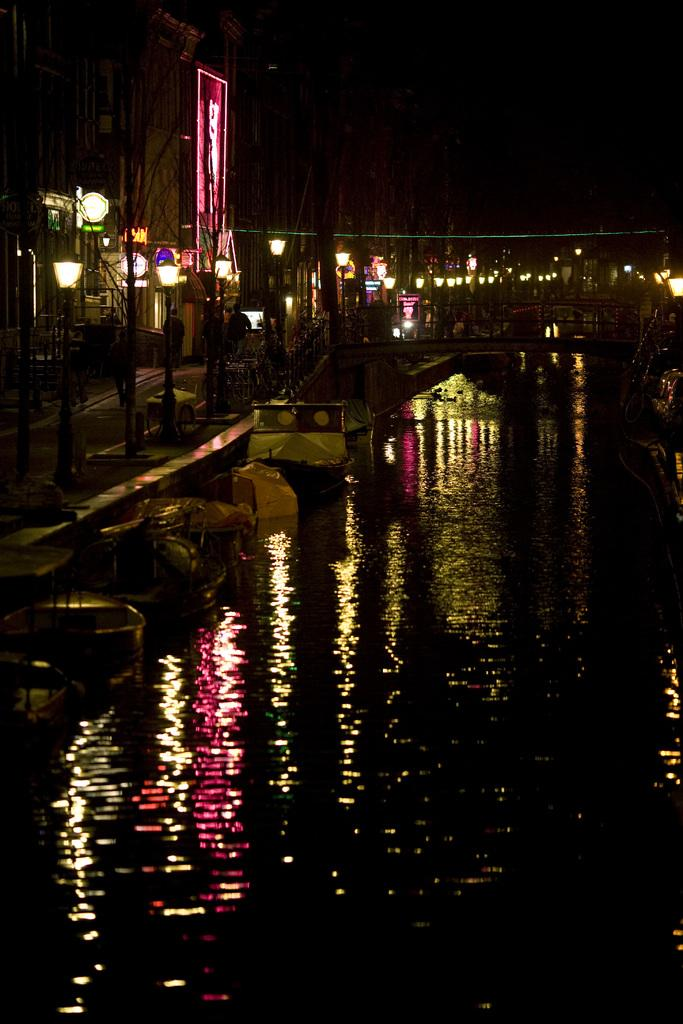What can be seen floating in the water body in the image? There are boats in the water body in the image. What structure connects the two sides of the water body? There is a bridge in the image. What type of lighting is present in the image? Street lamps are present in the image. What are the vertical structures in the image used for? Poles are visible in the image, which may be used for various purposes such as holding street lamps or signs. What type of vegetation is present in the image? Trees are present in the image. What type of man-made structure is visible in the image? There is a building in the image. What type of signage is visible in the image? A signboard with text is visible in the image. What part of the natural environment is visible in the image? The sky is visible in the image. Where is the nest of the bird in the image? There is no bird or nest present in the image. What type of celestial object can be seen in the image? There are no celestial objects visible in the image, such as stars. 